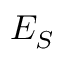Convert formula to latex. <formula><loc_0><loc_0><loc_500><loc_500>E _ { S }</formula> 